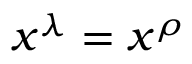<formula> <loc_0><loc_0><loc_500><loc_500>x ^ { \lambda } = x ^ { \rho }</formula> 